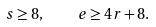Convert formula to latex. <formula><loc_0><loc_0><loc_500><loc_500>s \geq 8 , \quad e \geq 4 r + 8 .</formula> 